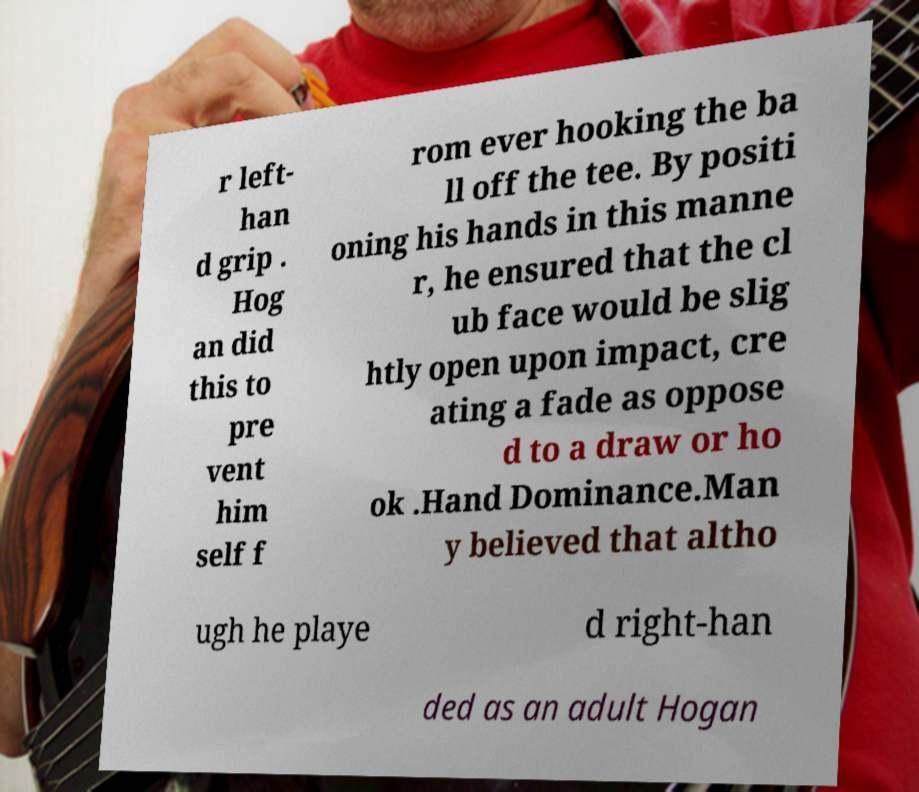Can you accurately transcribe the text from the provided image for me? r left- han d grip . Hog an did this to pre vent him self f rom ever hooking the ba ll off the tee. By positi oning his hands in this manne r, he ensured that the cl ub face would be slig htly open upon impact, cre ating a fade as oppose d to a draw or ho ok .Hand Dominance.Man y believed that altho ugh he playe d right-han ded as an adult Hogan 